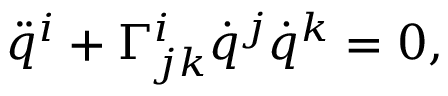<formula> <loc_0><loc_0><loc_500><loc_500>\begin{array} { r } { \ddot { q } ^ { i } + \Gamma _ { j k } ^ { i } \dot { q } ^ { j } \dot { q } ^ { k } = 0 , } \end{array}</formula> 